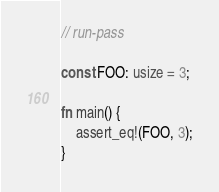<code> <loc_0><loc_0><loc_500><loc_500><_Rust_>// run-pass

const FOO: usize = 3;

fn main() {
    assert_eq!(FOO, 3);
}
</code> 